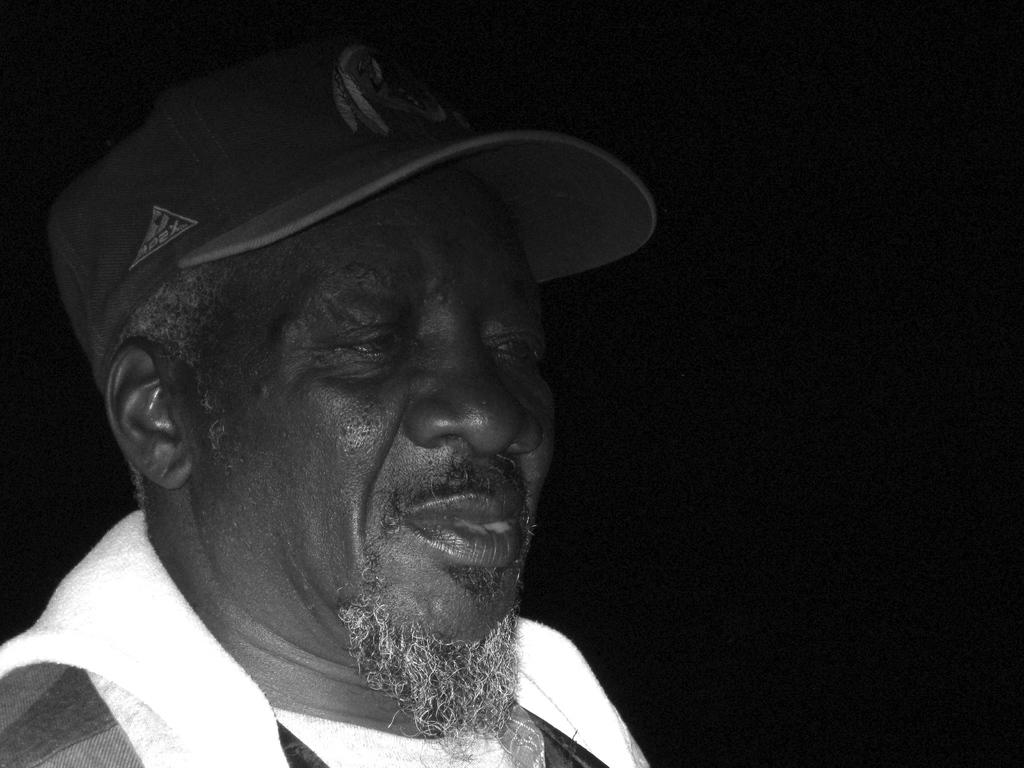Who is present on the left side of the image? There is a person on the left side of the image. What is the person wearing on their head? The person is wearing a cap. What color is the background of the image? The background of the image is black. What type of toy can be seen on the seashore in the image? There is no seashore or toy present in the image; it features a person wearing a cap with a black background. 